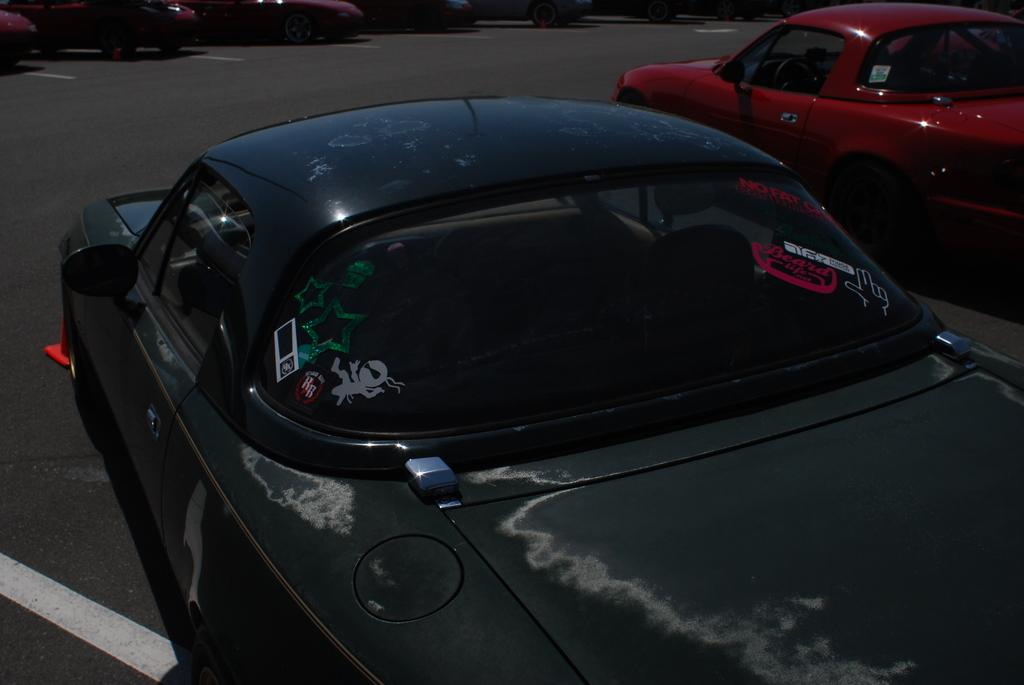What can be seen on the road in the image? There are vehicles on the road in the image. Can you describe the vehicles in the image? The provided facts do not give specific details about the vehicles, so we cannot describe them further. What might be the purpose of the vehicles on the road? The vehicles on the road may be used for transportation, either for people or goods. What type of steel is used to construct the berry in the image? There is no berry present in the image, and therefore no steel construction can be associated with it. 